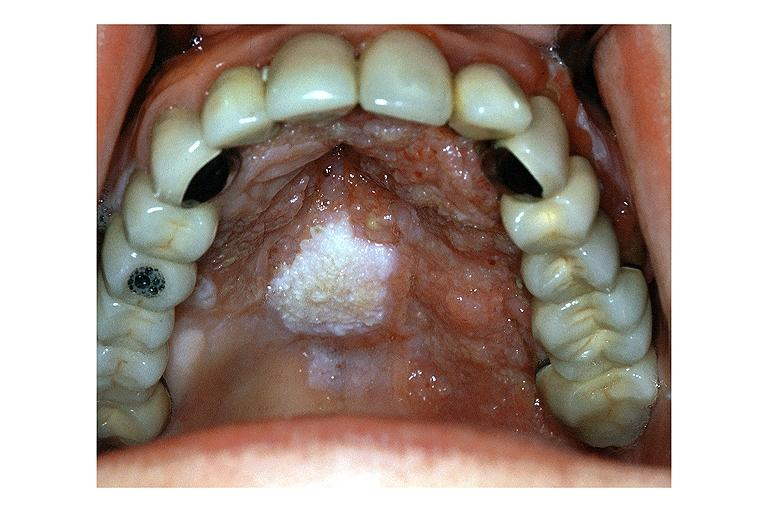does supernumerary digit show verrucous carcinoma?
Answer the question using a single word or phrase. No 